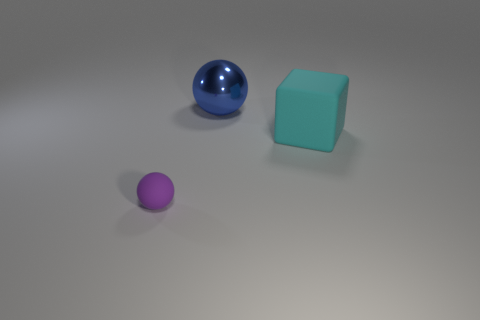How does the lighting in the scene affect the appearance of the different textured objects? The lighting creates soft shadows and highlights which enhance the metallic texture of the blue sphere, giving it a shiny appearance. The matte finish of the purple sphere and cyan block diffuses the light, resulting in softer, less reflective surfaces. 